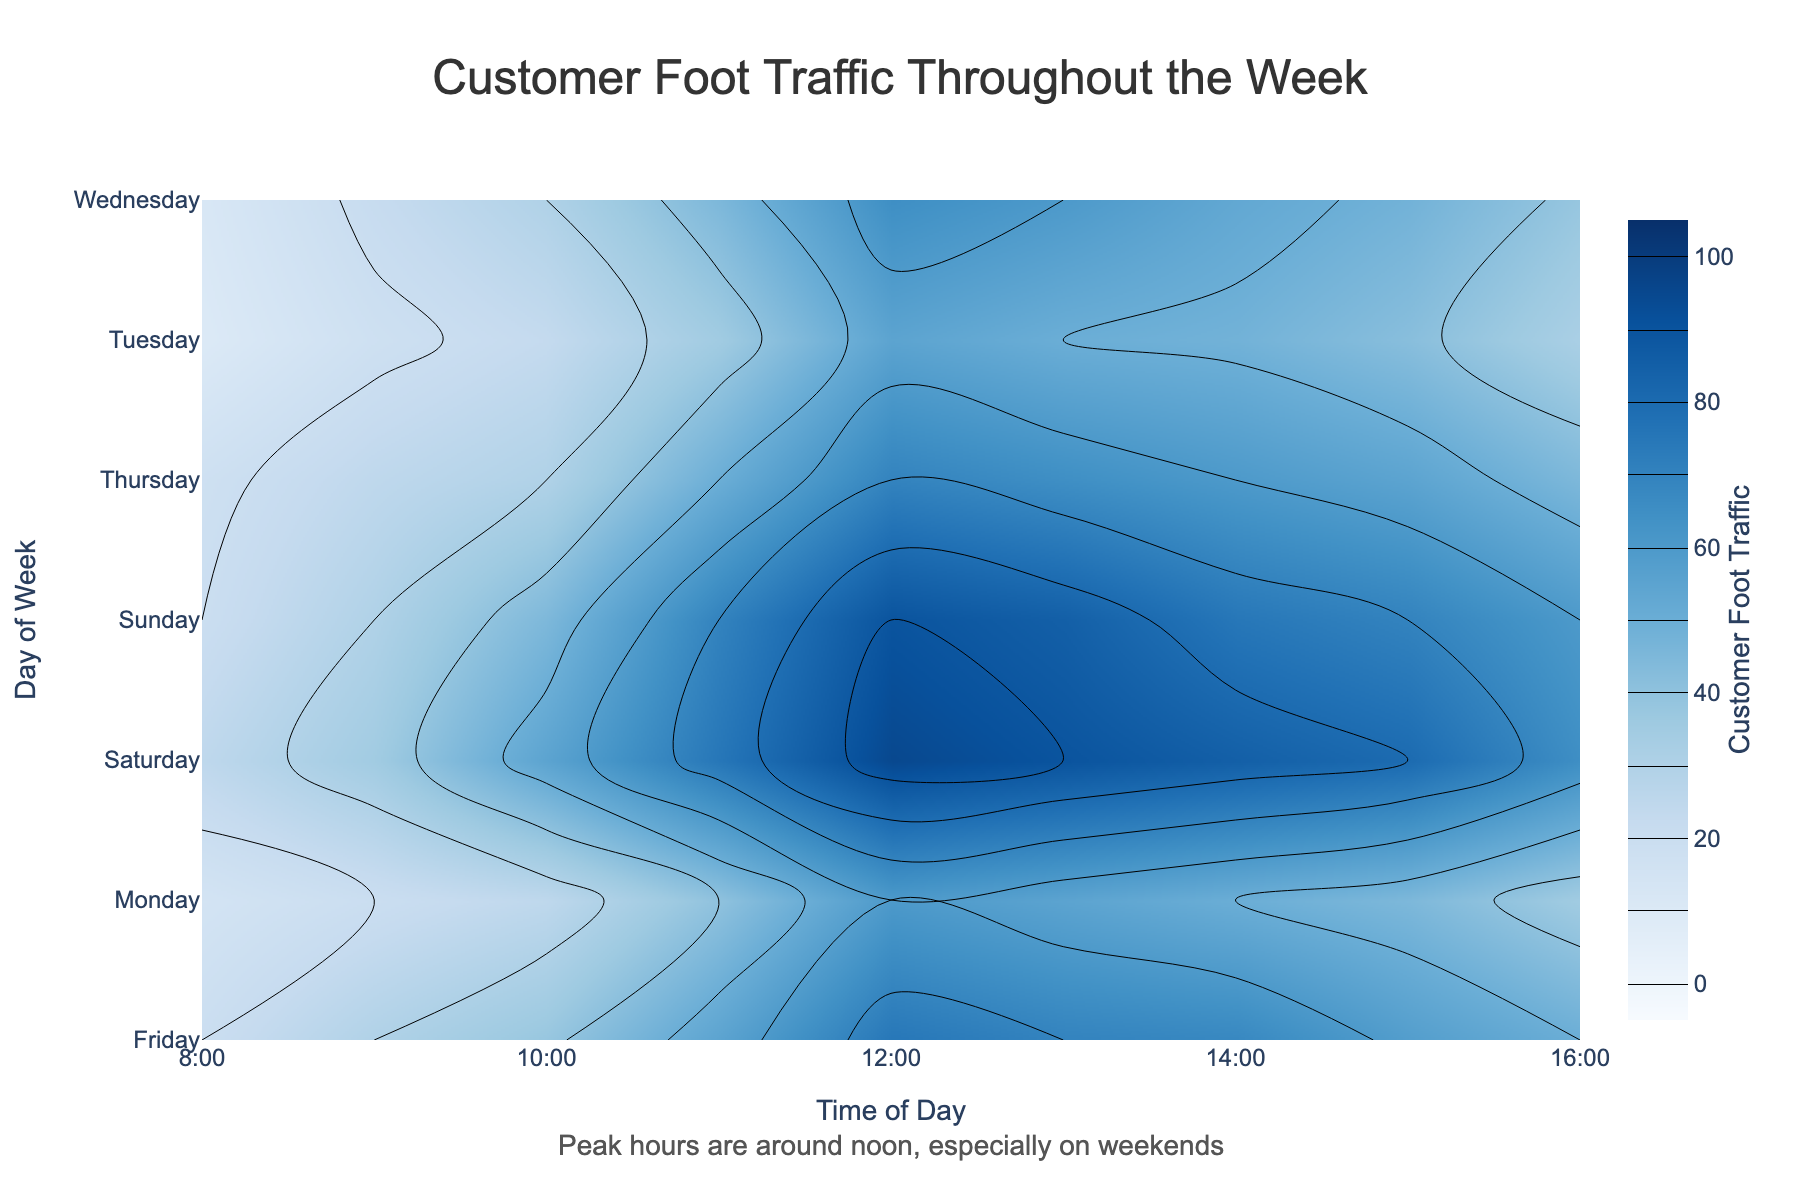What's the title of the figure? The title of the figure shows prominently at the top of the plot area in a larger font and provides a summary of what the chart is about.
Answer: Customer Foot Traffic Throughout the Week Which time of day sees the peak customer foot traffic on Saturday? Observing the contour levels, the color at 12:00 PM on Saturday indicates peak customer traffic.
Answer: Around noon Compare customer foot traffic between Monday and Wednesday at 3:00 PM. Which day has higher traffic? By finding 3:00 PM on the x-axis and checking the contour levels for Monday and Wednesday, you can see Wednesday has higher levels.
Answer: Wednesday What is the range of customer foot traffic values represented in the color bar? The color bar, usually located next to the plot, shows the range of values the colors represent.
Answer: 0 to 100 What trend is observable in customer foot traffic from Monday to Sunday at 12:00 PM? Following the contour levels along the 12:00 PM (noon) mark horizontally from Monday to Sunday, you can see an increasing trend in traffic.
Answer: Increasing trend Which day shows the least variation in customer foot traffic throughout the day? By looking at the contour plot and comparing the bands of color on each day, Tuesday shows the least variation in traffic levels.
Answer: Tuesday Determine the time of day with the lowest customer foot traffic across all days. By finding the lowest levels on the color scale and checking which times these levels appear at across all days, the early morning hours like 8:00 AM show the lowest traffic.
Answer: 8:00 AM How does customer foot traffic at 2:00 PM on Friday compare to that on Sunday? By locating 2:00 PM on the x-axis and comparing Friday and Sunday based on the contour shading, Sunday has higher traffic.
Answer: Sunday Which segment of the week (weekdays vs. weekends) generally observes higher customer foot traffic? By comparing the contour levels from Monday to Friday and then Saturday and Sunday, weekends show higher traffic.
Answer: Weekends 